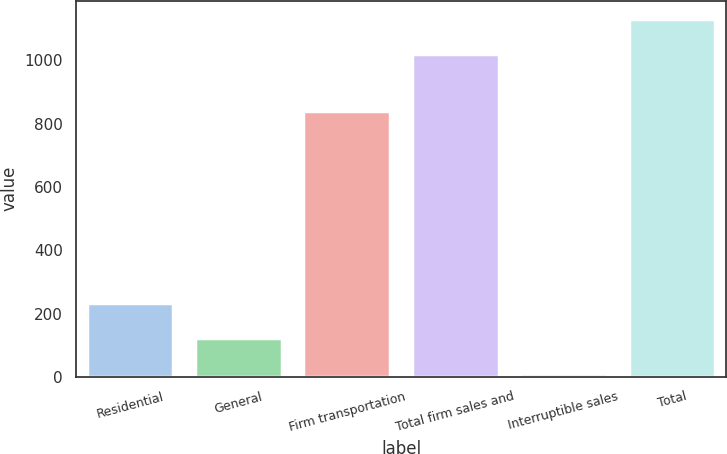<chart> <loc_0><loc_0><loc_500><loc_500><bar_chart><fcel>Residential<fcel>General<fcel>Firm transportation<fcel>Total firm sales and<fcel>Interruptible sales<fcel>Total<nl><fcel>232<fcel>121.5<fcel>840<fcel>1021<fcel>11<fcel>1131.5<nl></chart> 